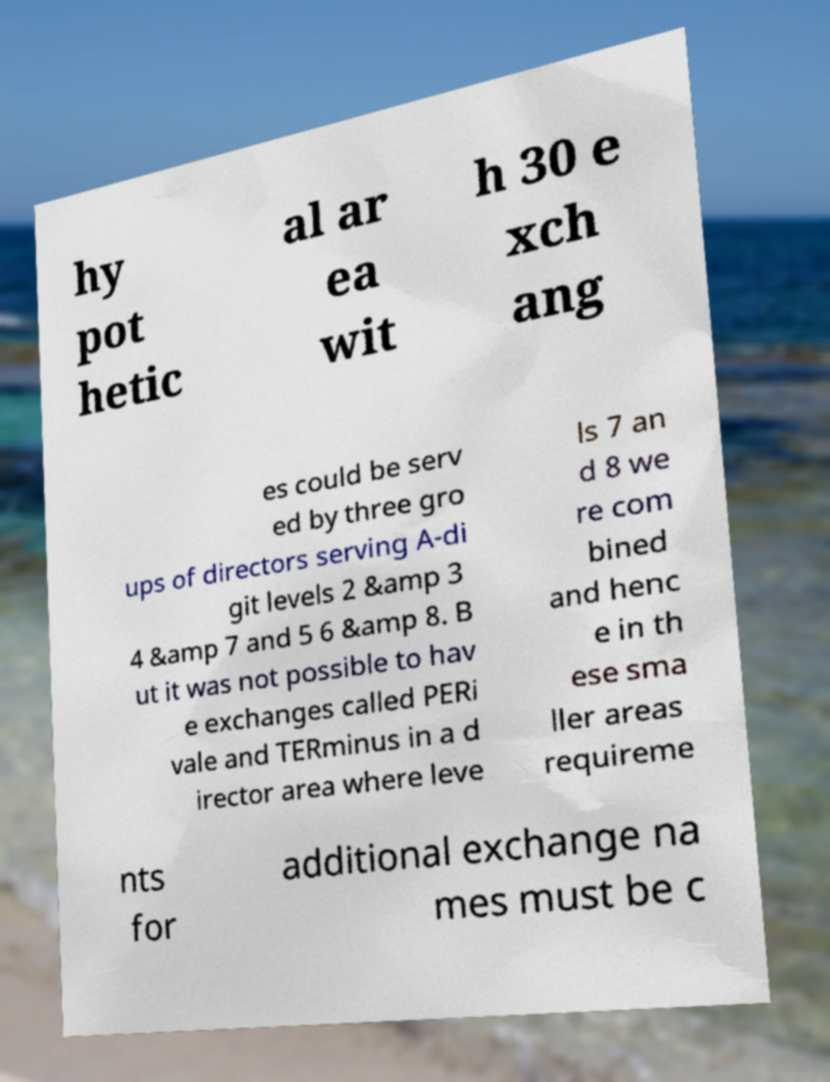Please identify and transcribe the text found in this image. hy pot hetic al ar ea wit h 30 e xch ang es could be serv ed by three gro ups of directors serving A-di git levels 2 &amp 3 4 &amp 7 and 5 6 &amp 8. B ut it was not possible to hav e exchanges called PERi vale and TERminus in a d irector area where leve ls 7 an d 8 we re com bined and henc e in th ese sma ller areas requireme nts for additional exchange na mes must be c 